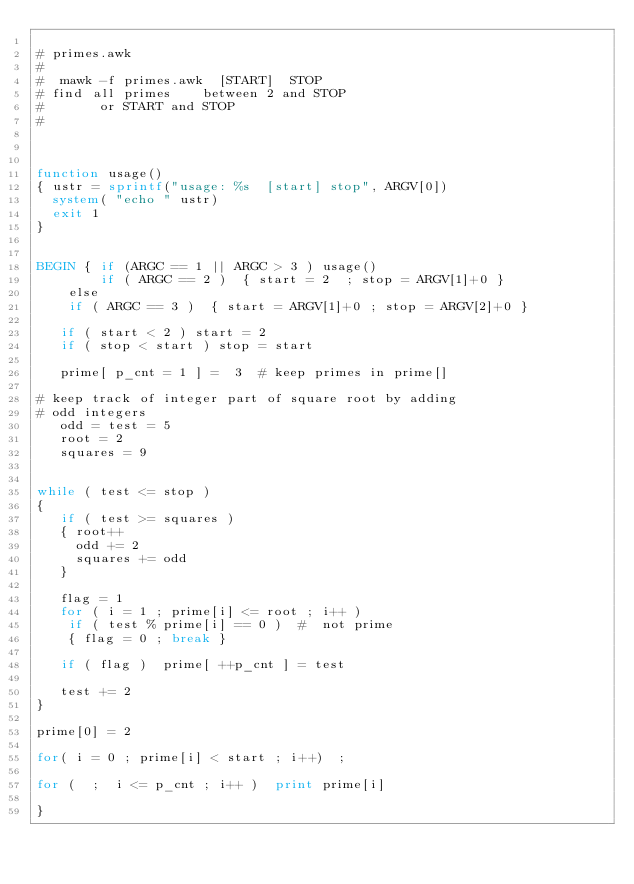<code> <loc_0><loc_0><loc_500><loc_500><_Awk_>
# primes.awk
#
#  mawk -f primes.awk  [START]  STOP
# find all primes    between 2 and STOP
#       or START and STOP
#



function usage()
{ ustr = sprintf("usage: %s  [start] stop", ARGV[0])
  system( "echo " ustr) 
  exit 1
}


BEGIN { if (ARGC == 1 || ARGC > 3 ) usage()
        if ( ARGC == 2 )  { start = 2  ; stop = ARGV[1]+0 }
	else
	if ( ARGC == 3 )  { start = ARGV[1]+0 ; stop = ARGV[2]+0 }

   if ( start < 2 ) start = 2
   if ( stop < start ) stop = start

   prime[ p_cnt = 1 ] =  3  # keep primes in prime[]

# keep track of integer part of square root by adding
# odd integers 
   odd = test = 5
   root = 2
   squares = 9

   
while ( test <= stop )
{
   if ( test >= squares )
   { root++
     odd += 2
     squares += odd 
   }

   flag = 1
   for ( i = 1 ; prime[i] <= root ; i++ )
   	if ( test % prime[i] == 0 )  #  not prime
	{ flag = 0 ; break }

   if ( flag )  prime[ ++p_cnt ] = test

   test += 2
}

prime[0] = 2

for( i = 0 ; prime[i] < start ; i++)  ;

for (  ;  i <= p_cnt ; i++ )  print prime[i]

}


     
</code> 